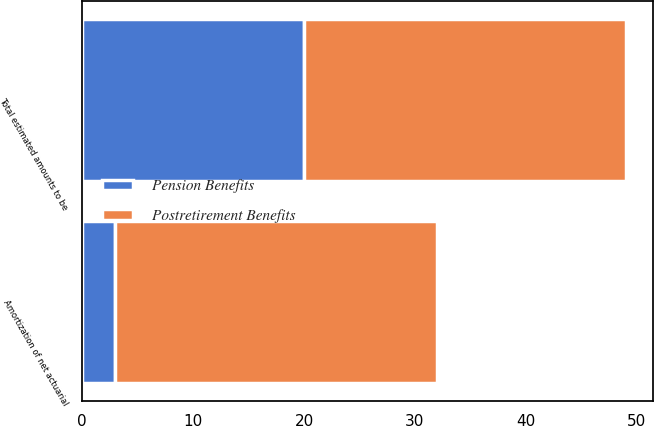<chart> <loc_0><loc_0><loc_500><loc_500><stacked_bar_chart><ecel><fcel>Amortization of net actuarial<fcel>Total estimated amounts to be<nl><fcel>Postretirement Benefits<fcel>29<fcel>29<nl><fcel>Pension Benefits<fcel>3<fcel>20<nl></chart> 